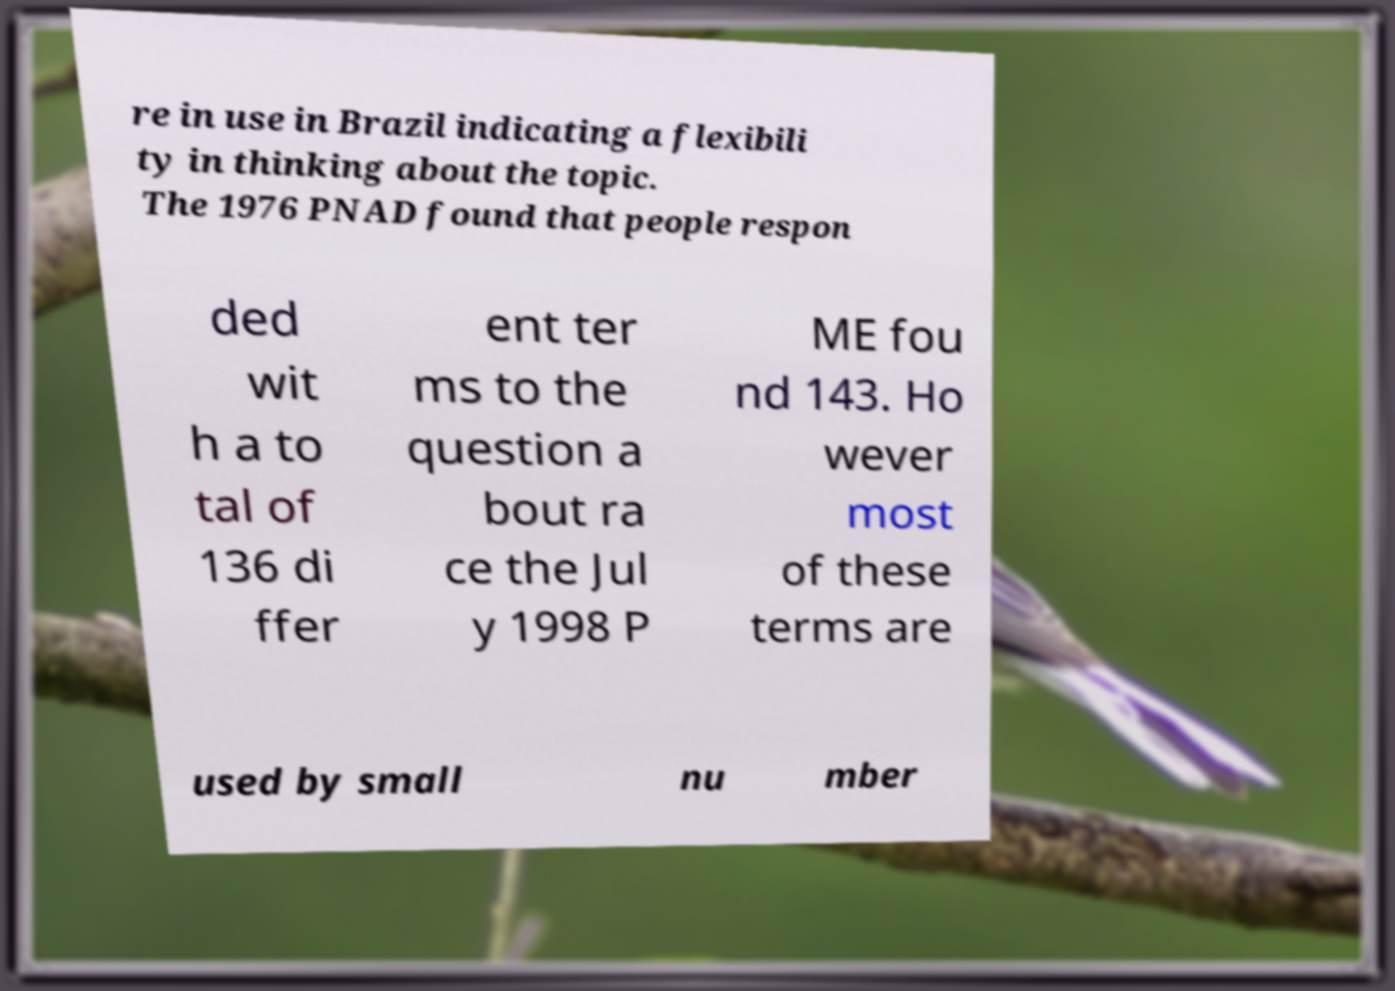Could you extract and type out the text from this image? re in use in Brazil indicating a flexibili ty in thinking about the topic. The 1976 PNAD found that people respon ded wit h a to tal of 136 di ffer ent ter ms to the question a bout ra ce the Jul y 1998 P ME fou nd 143. Ho wever most of these terms are used by small nu mber 